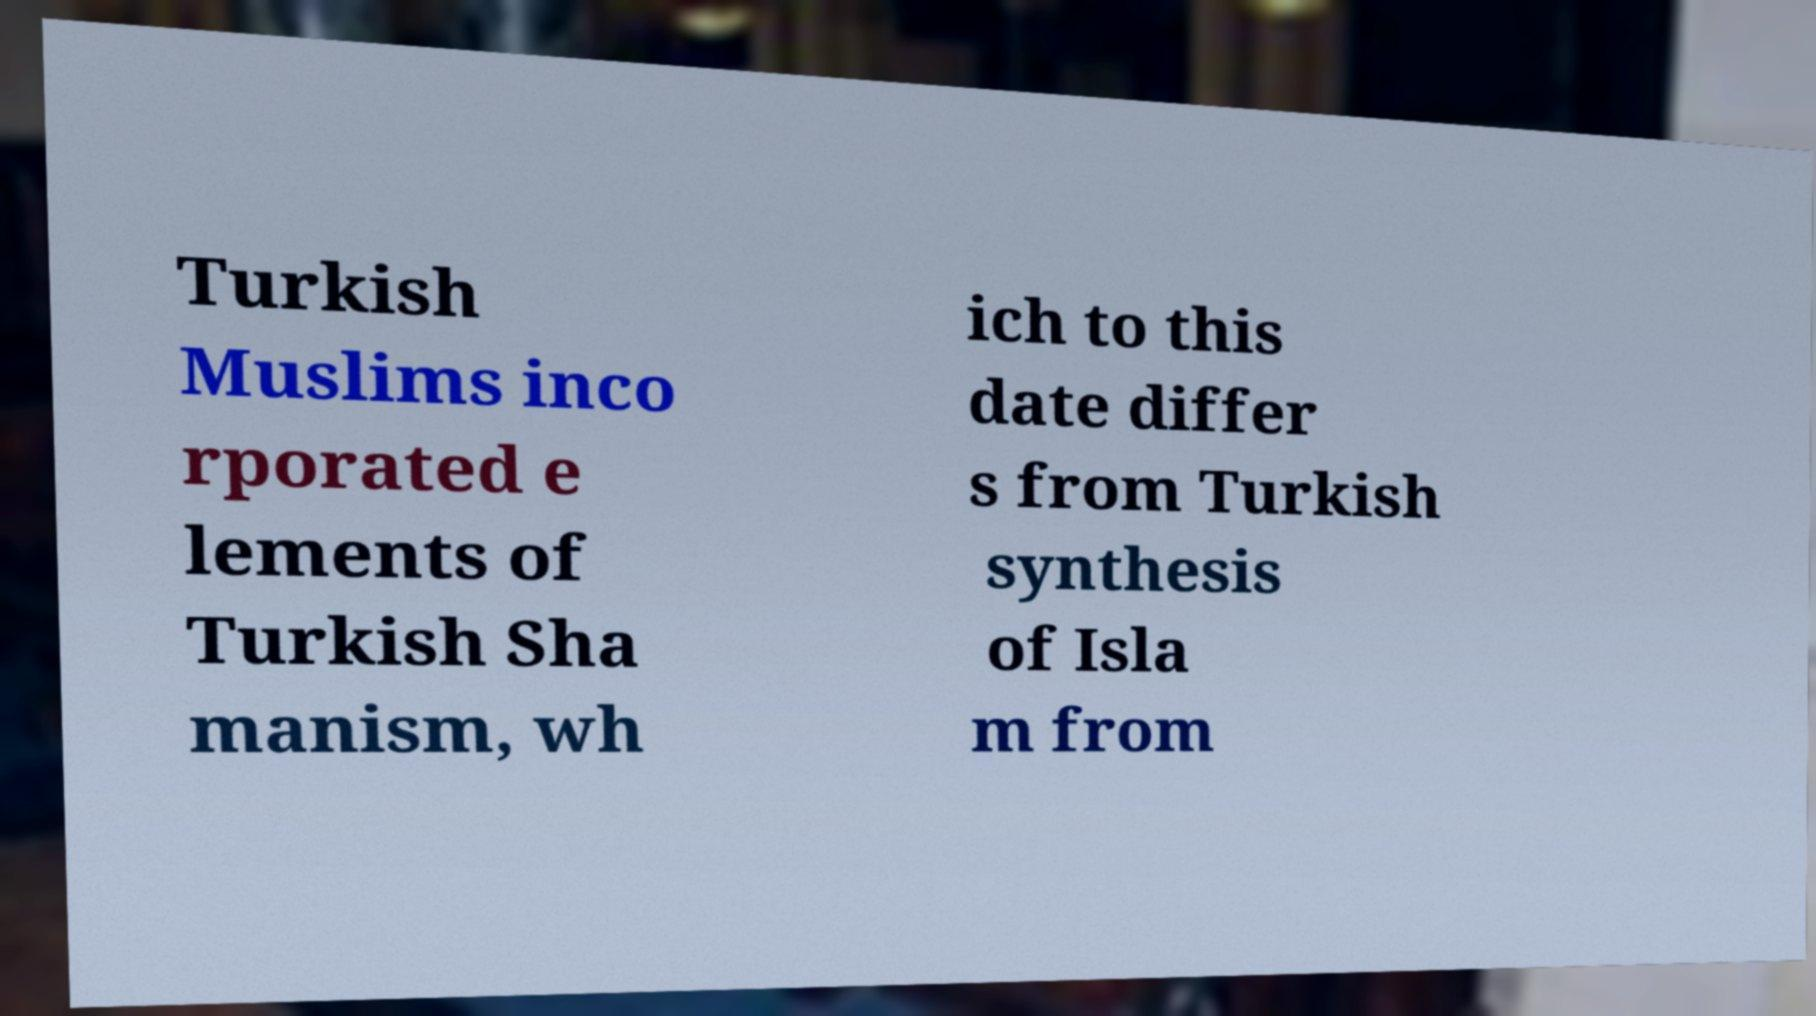What messages or text are displayed in this image? I need them in a readable, typed format. Turkish Muslims inco rporated e lements of Turkish Sha manism, wh ich to this date differ s from Turkish synthesis of Isla m from 